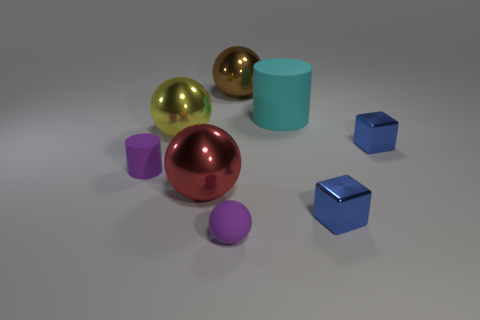Add 2 big brown metallic balls. How many objects exist? 10 Subtract all cylinders. How many objects are left? 6 Add 8 purple cylinders. How many purple cylinders are left? 9 Add 4 small red shiny blocks. How many small red shiny blocks exist? 4 Subtract 0 brown blocks. How many objects are left? 8 Subtract all cyan matte cubes. Subtract all yellow objects. How many objects are left? 7 